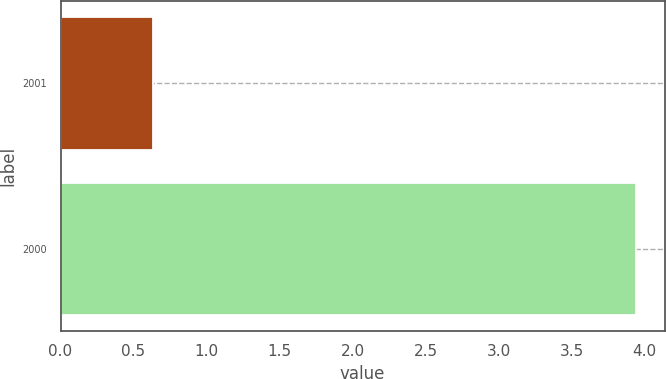<chart> <loc_0><loc_0><loc_500><loc_500><bar_chart><fcel>2001<fcel>2000<nl><fcel>0.63<fcel>3.94<nl></chart> 